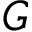Convert formula to latex. <formula><loc_0><loc_0><loc_500><loc_500>G</formula> 